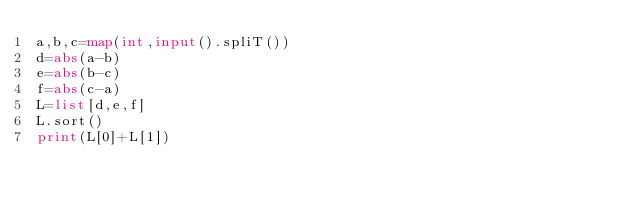Convert code to text. <code><loc_0><loc_0><loc_500><loc_500><_Python_>a,b,c=map(int,input().spliT())
d=abs(a-b)
e=abs(b-c)
f=abs(c-a)
L=list[d,e,f]
L.sort()
print(L[0]+L[1])


</code> 